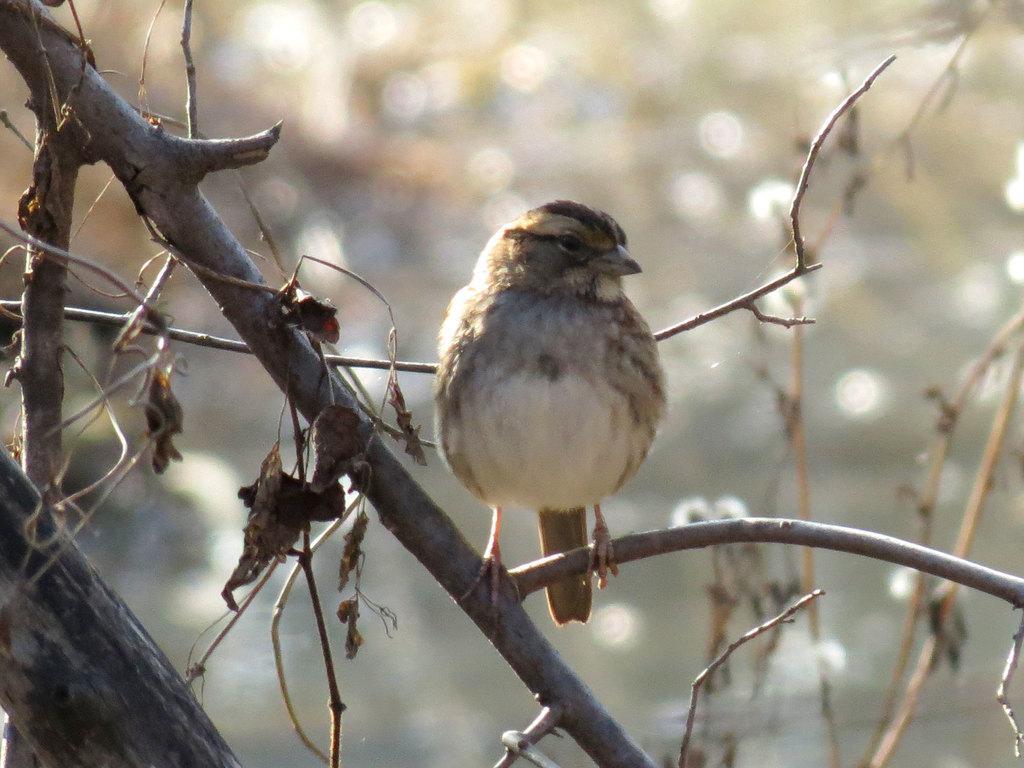Please provide a concise description of this image. In this picture I can see in the middle a bird is standing on the branch of a tree. 